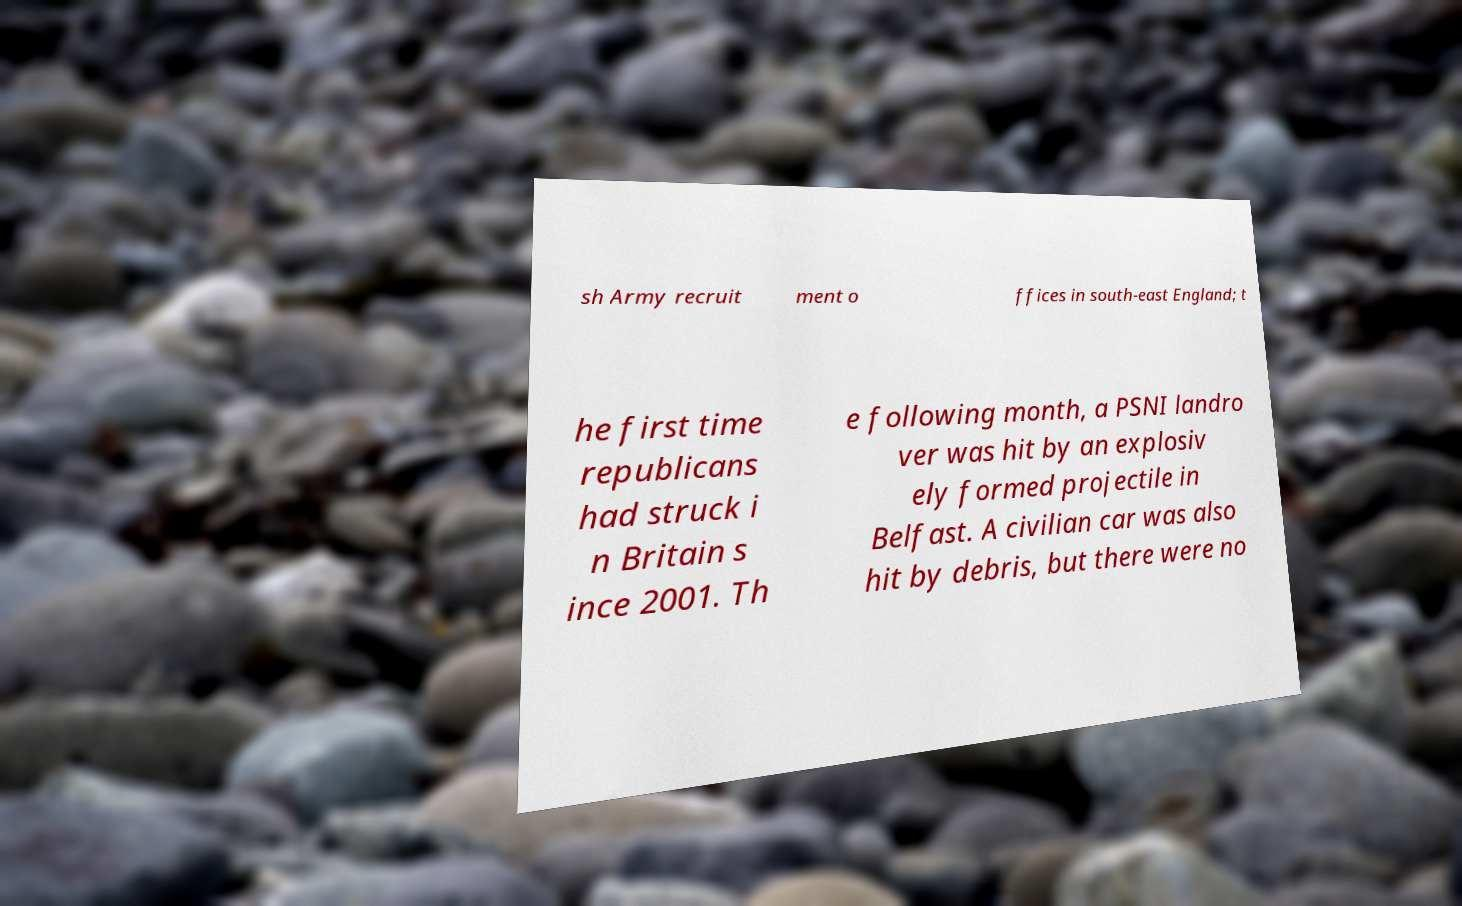What messages or text are displayed in this image? I need them in a readable, typed format. sh Army recruit ment o ffices in south-east England; t he first time republicans had struck i n Britain s ince 2001. Th e following month, a PSNI landro ver was hit by an explosiv ely formed projectile in Belfast. A civilian car was also hit by debris, but there were no 